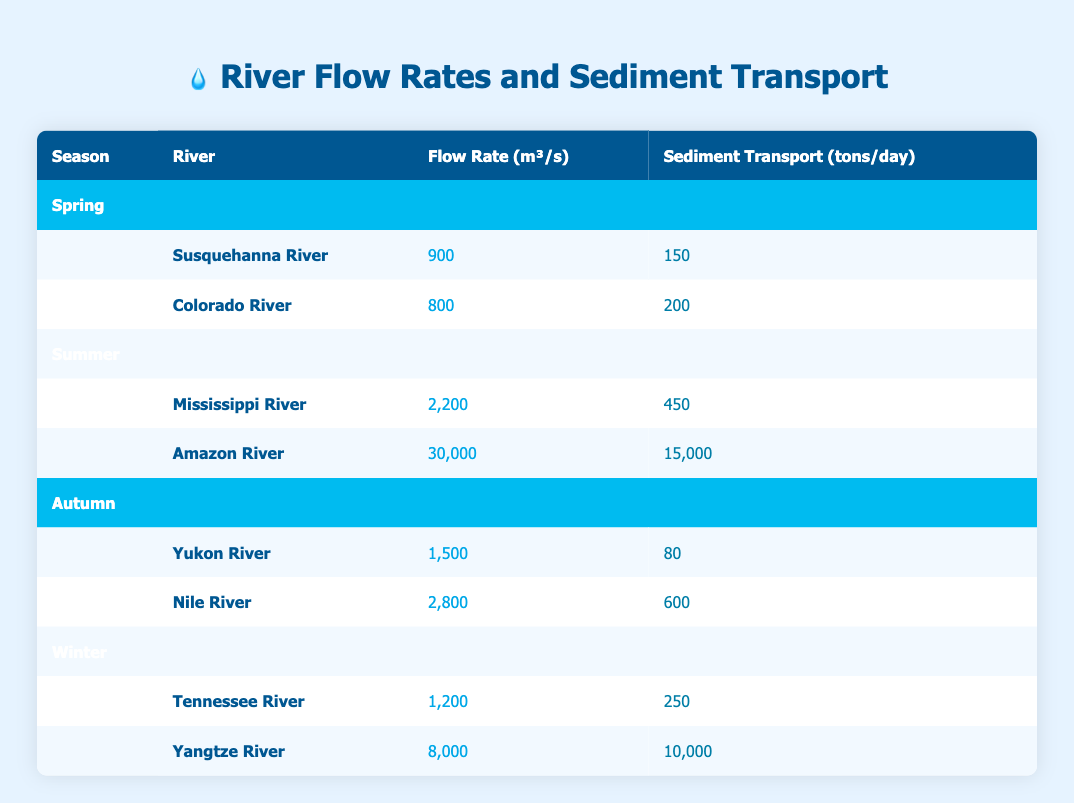What is the flow rate of the Colorado River? The flow rate for the Colorado River is specified in the table under the Spring season, which shows a value of 800 cubic meters per second.
Answer: 800 Which river has the highest sediment transport measurement in the Summer? In the Summer section, the Amazon River has a sediment transport value of 15,000 tons per day, which is greater than the Mississippi River's value of 450 tons per day.
Answer: Amazon River What is the total flow rate for all rivers in Autumn? The rivers listed in Autumn are the Yukon River with a flow rate of 1,500 m³/s and the Nile River with a flow rate of 2,800 m³/s. The total flow rate is calculated as 1,500 + 2,800 = 4,300 cubic meters per second.
Answer: 4,300 Is the sediment transport of the Yangtze River greater than 1,000 tons per day? The sediment transport for the Yangtze River is provided in the Winter section and is specified as 10,000 tons per day, which is greater than 1,000 tons per day.
Answer: Yes What is the average flow rate of rivers during the Spring? The spring rivers are the Susquehanna River with a flow rate of 900 m³/s and the Colorado River with a flow rate of 800 m³/s. The average is calculated as (900 + 800) / 2 = 850 cubic meters per second.
Answer: 850 